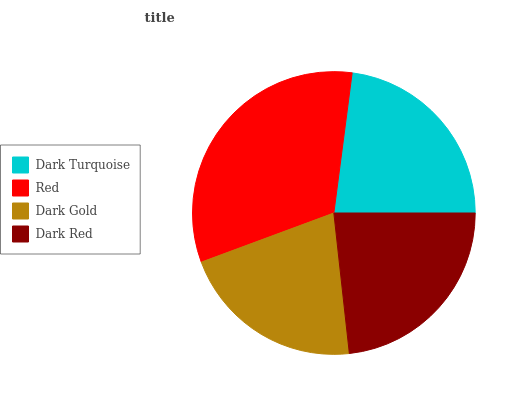Is Dark Gold the minimum?
Answer yes or no. Yes. Is Red the maximum?
Answer yes or no. Yes. Is Red the minimum?
Answer yes or no. No. Is Dark Gold the maximum?
Answer yes or no. No. Is Red greater than Dark Gold?
Answer yes or no. Yes. Is Dark Gold less than Red?
Answer yes or no. Yes. Is Dark Gold greater than Red?
Answer yes or no. No. Is Red less than Dark Gold?
Answer yes or no. No. Is Dark Red the high median?
Answer yes or no. Yes. Is Dark Turquoise the low median?
Answer yes or no. Yes. Is Red the high median?
Answer yes or no. No. Is Red the low median?
Answer yes or no. No. 